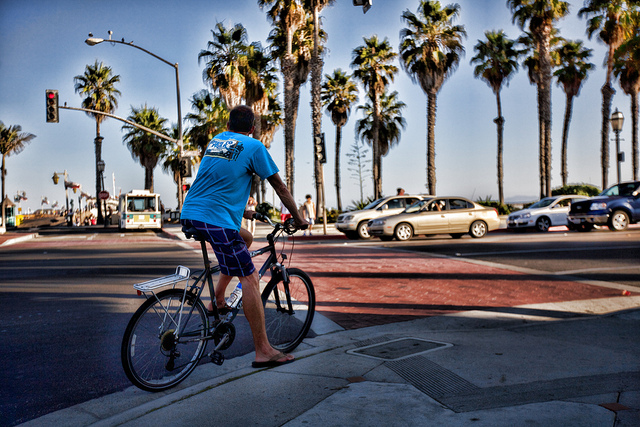<image>Is the guy on the bike going to the beach? It is ambiguous whether the guy on the bike is going to the beach. It could be yes or no. Is the guy on the bike going to the beach? I don't know if the guy on the bike is going to the beach. It is possible, but I am not certain. 